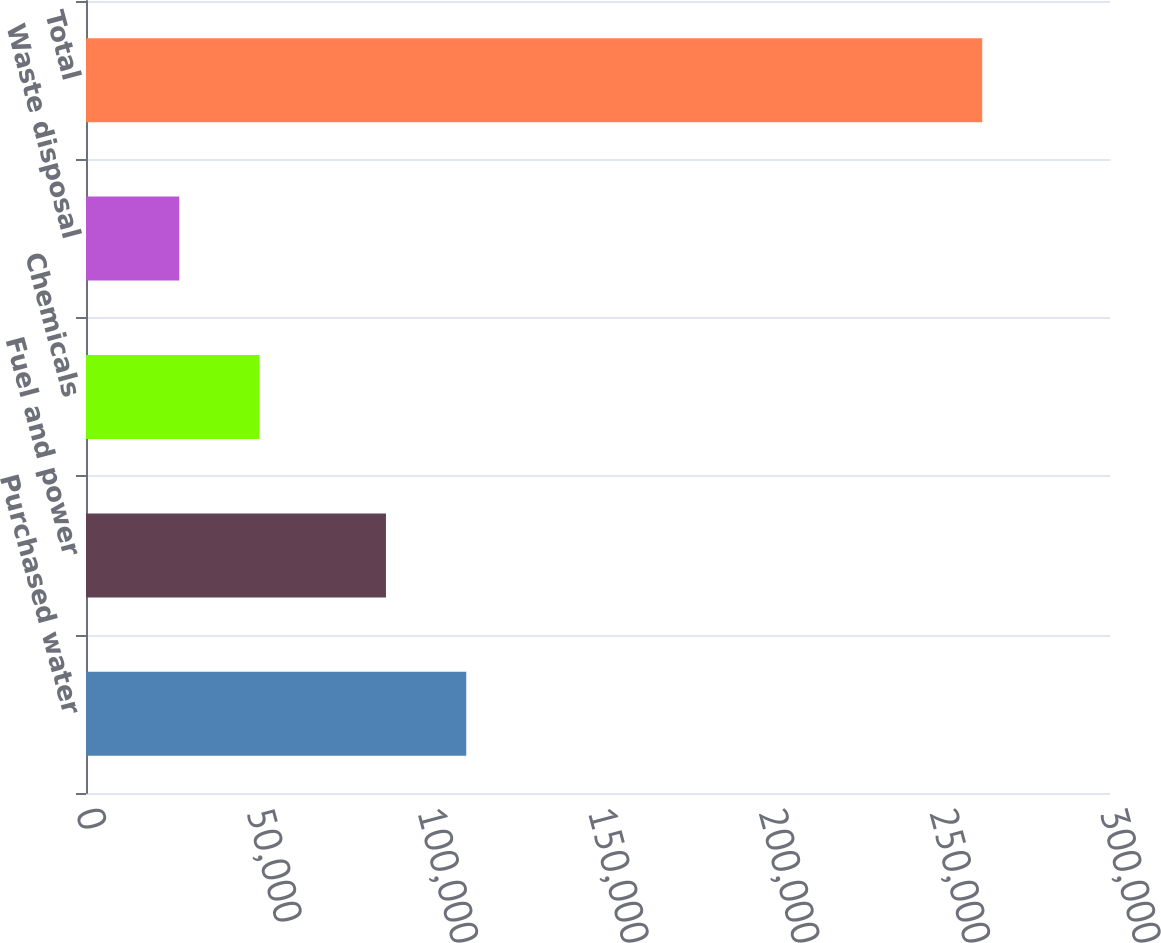Convert chart. <chart><loc_0><loc_0><loc_500><loc_500><bar_chart><fcel>Purchased water<fcel>Fuel and power<fcel>Chemicals<fcel>Waste disposal<fcel>Total<nl><fcel>111403<fcel>87879<fcel>50846.1<fcel>27322<fcel>262563<nl></chart> 